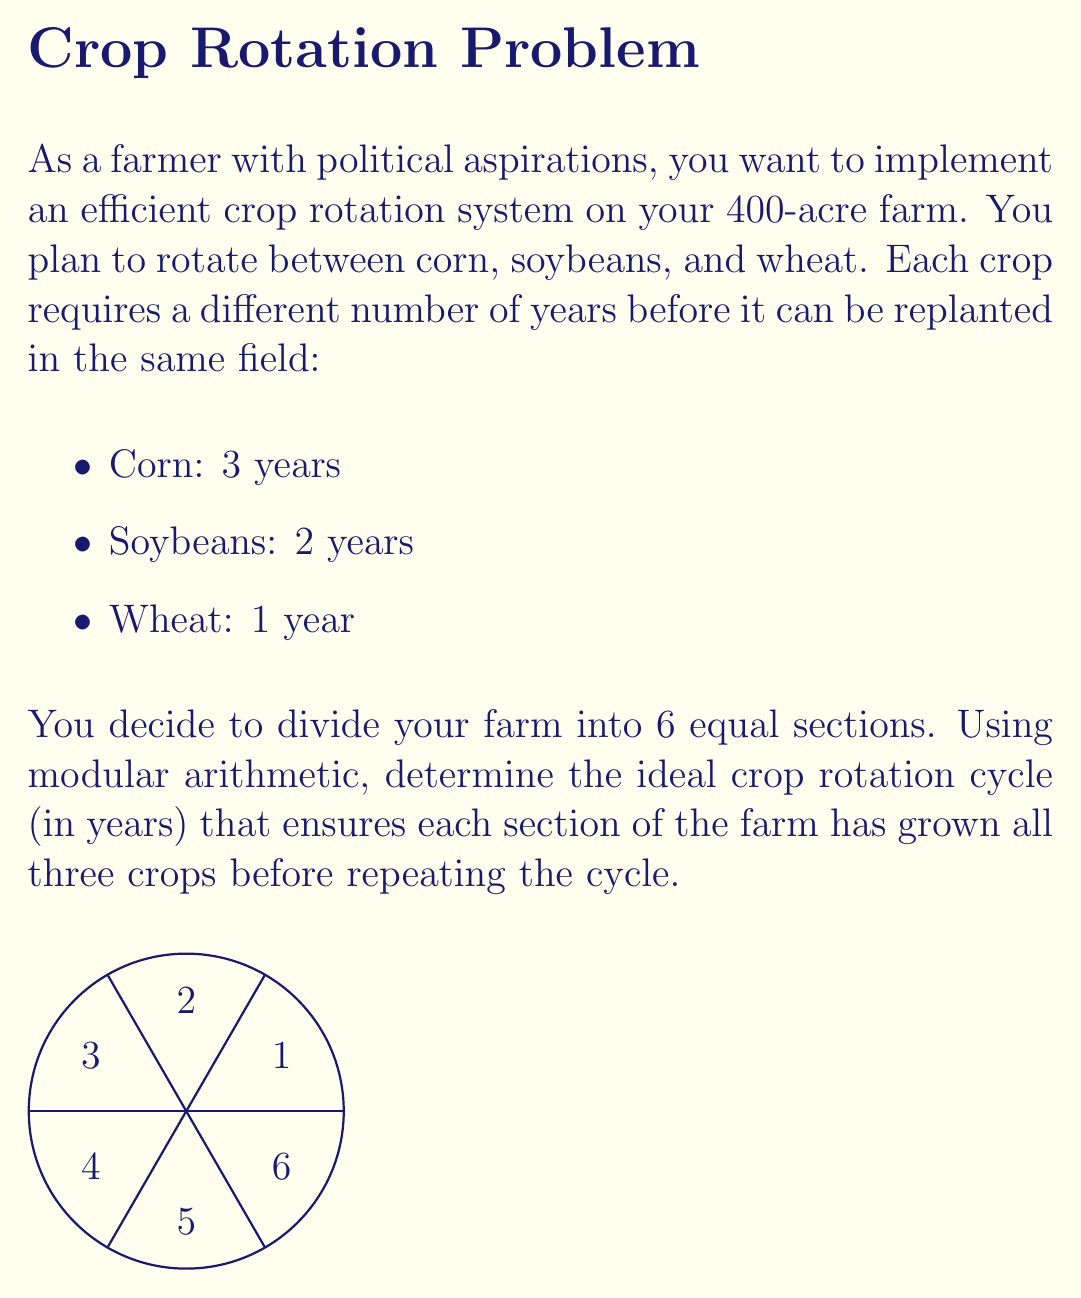What is the answer to this math problem? Let's approach this step-by-step using modular arithmetic:

1) First, we need to find the least common multiple (LCM) of the years required for each crop:
   LCM(3, 2, 1) = 6

2) This means that after 6 years, we can potentially repeat the cycle for any given section.

3) Now, we need to check if 6 years is enough for all 6 sections to grow all 3 crops:

   Let's use modular arithmetic with mod 6 (since we have 6 sections):
   
   $$\begin{array}{c|ccc}
   \text{Year} & \text{Section 1} & \text{Section 2} & \text{Section 3} & \text{Section 4} & \text{Section 5} & \text{Section 6} \\
   \hline
   1 & C & S & W & C & S & W \\
   2 & S & W & C & S & W & C \\
   3 & W & C & S & W & C & S \\
   4 & C & S & W & C & S & W \\
   5 & S & W & C & S & W & C \\
   6 & W & C & S & W & C & S \\
   \end{array}$$

   Where C = Corn, S = Soybeans, W = Wheat

4) We can see that after 6 years, each section has grown all three crops and we're back to the initial configuration.

5) Therefore, the ideal crop rotation cycle is 6 years.

6) We can verify this using modular arithmetic:
   - For corn: $6 \equiv 0 \pmod{3}$
   - For soybeans: $6 \equiv 0 \pmod{2}$
   - For wheat: $6 \equiv 0 \pmod{1}$

   This confirms that 6 years satisfies the rotation requirements for all crops.
Answer: 6 years 